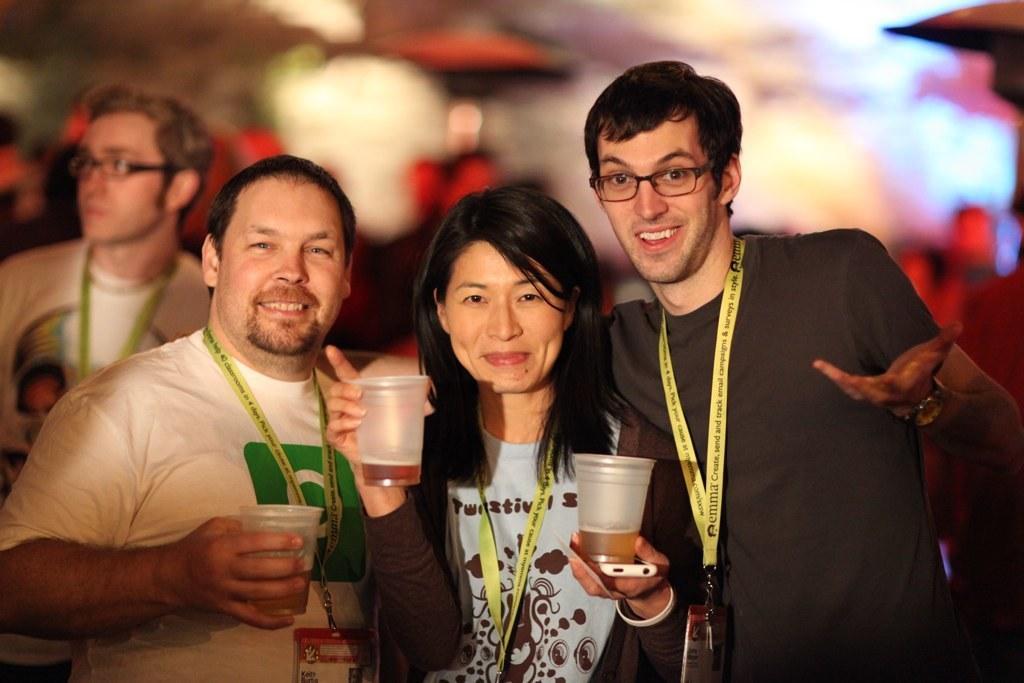How would you summarize this image in a sentence or two? Background is very blurry. here we can see three persons in front of a picture holding glasses in their hands and smiling. Here we can other man. He wore spectacles. 